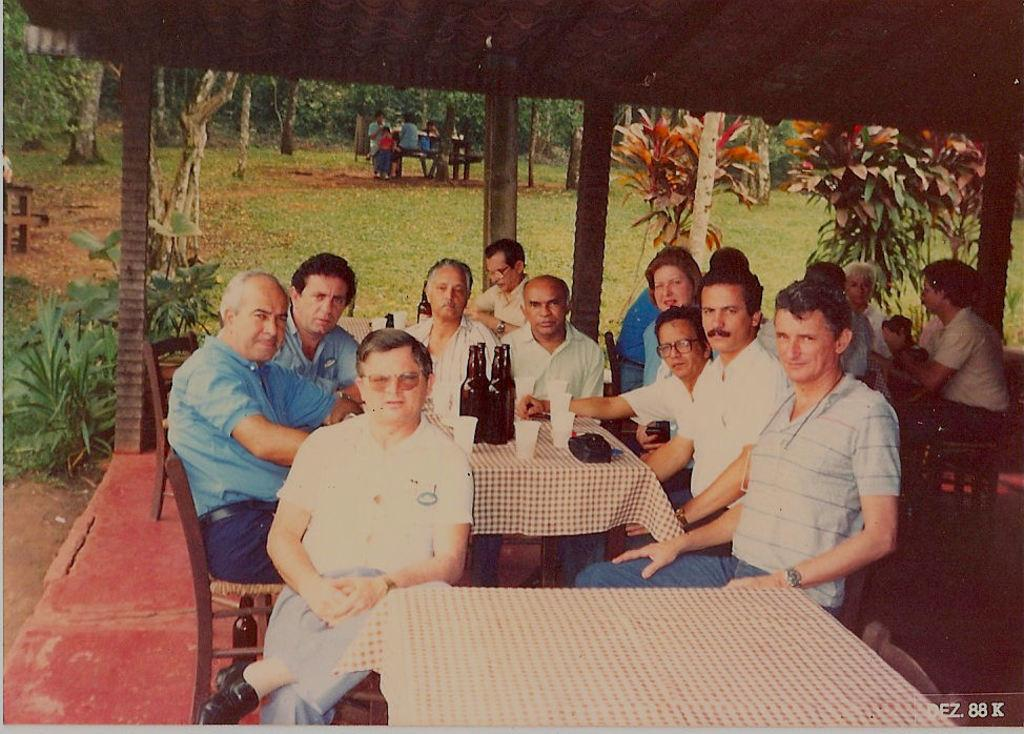What are the men in the image doing? The men in the image are sitting on chairs. What can be seen on the table in the image? There are wine bottles and glasses on the table. What is visible in the background of the image? There are trees visible in the background of the image. What type of cable can be seen hanging from the trees in the image? There is no cable visible in the image; only trees are present in the background. 